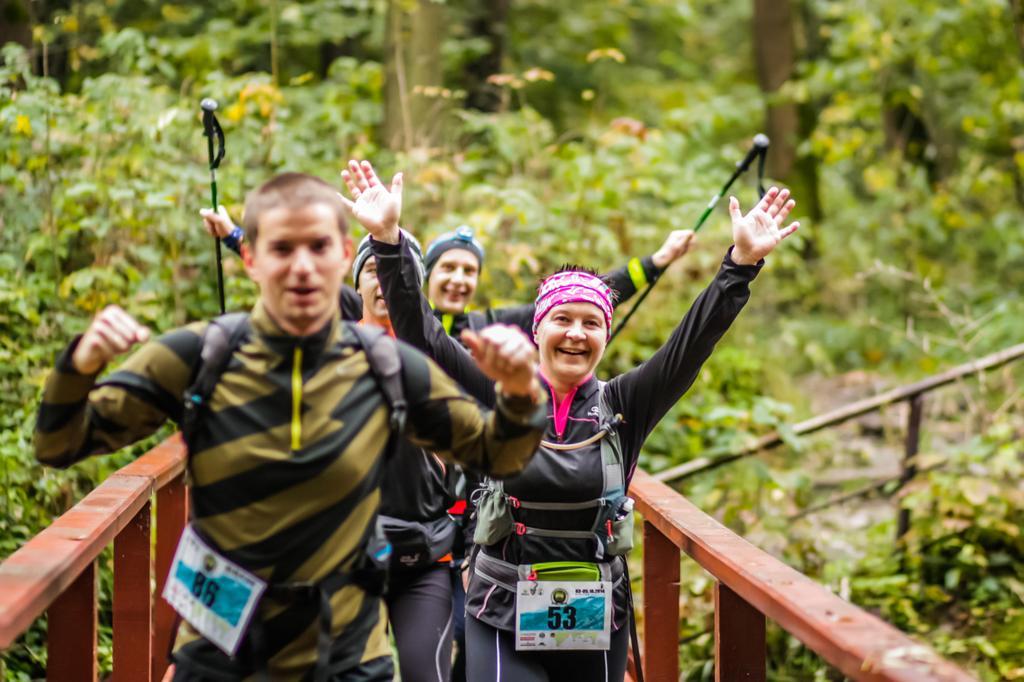Describe this image in one or two sentences. This image consists of four persons wearing bags. To the left and right there is a railing in brown color. 